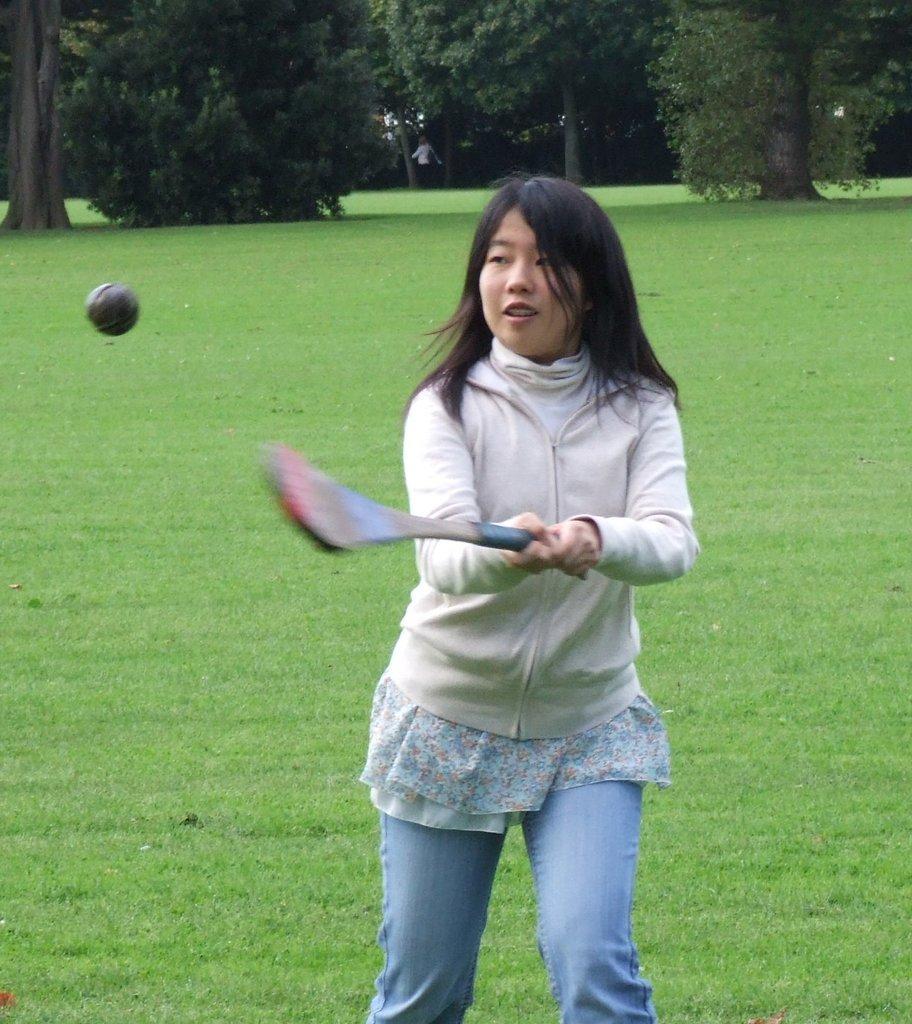In one or two sentences, can you explain what this image depicts? Here I can see girl wearing a jacket, jeans, holding a bat in the hands and playing with the ball. At the bottom of the image I can see the grass. In the background there are some trees and I can see a person is standing under the tree. 